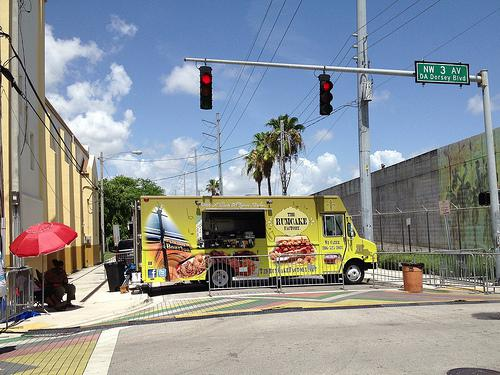Question: where was the photo taken?
Choices:
A. On Fifth Street.
B. On Gardner Street.
C. On Penial road.
D. At the intersection near NW 3rd Ave.
Answer with the letter. Answer: D Question: what color is the truck?
Choices:
A. Yellow.
B. Green.
C. Brown.
D. Black.
Answer with the letter. Answer: A 